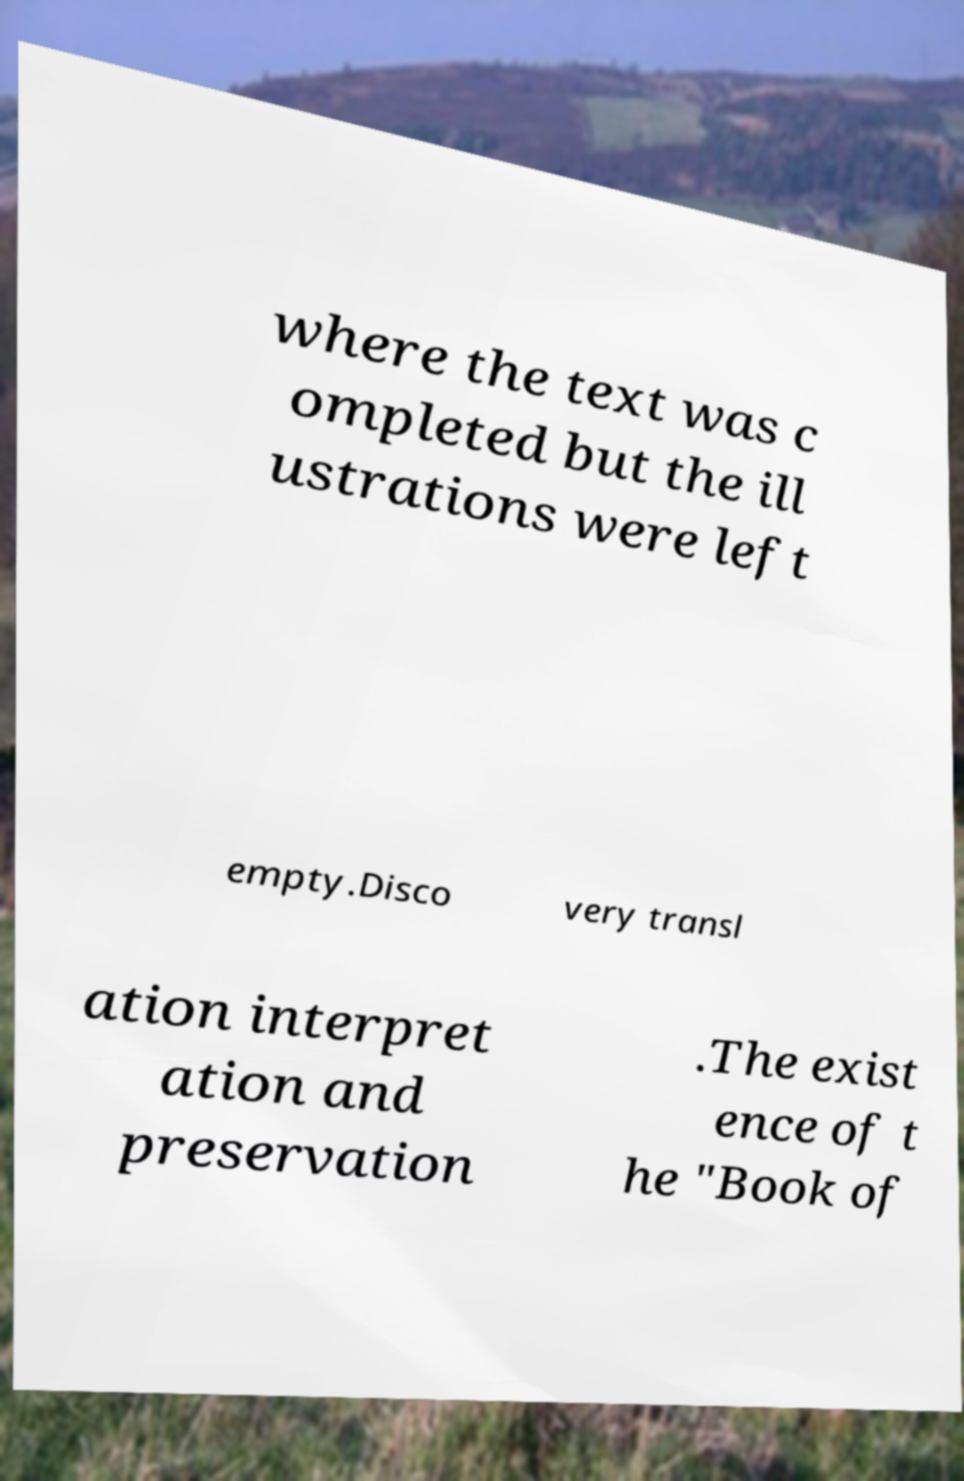I need the written content from this picture converted into text. Can you do that? where the text was c ompleted but the ill ustrations were left empty.Disco very transl ation interpret ation and preservation .The exist ence of t he "Book of 